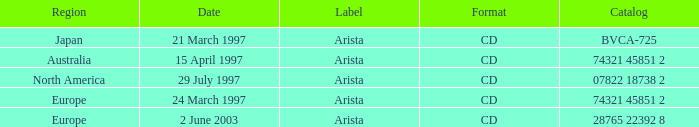What's the Date with the Region of Europe and has a Catalog of 28765 22392 8? 2 June 2003. 